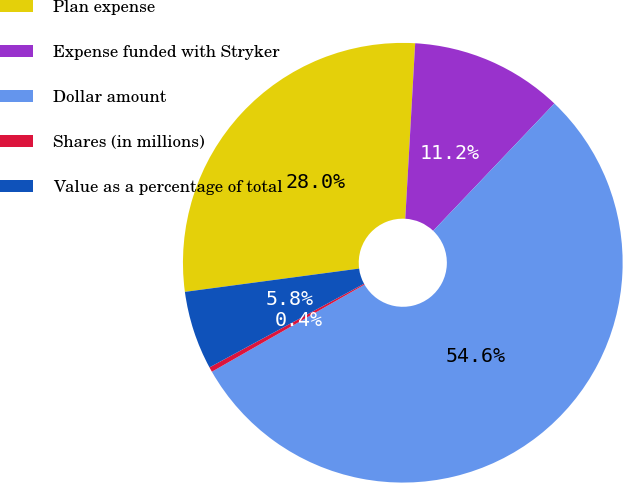Convert chart. <chart><loc_0><loc_0><loc_500><loc_500><pie_chart><fcel>Plan expense<fcel>Expense funded with Stryker<fcel>Dollar amount<fcel>Shares (in millions)<fcel>Value as a percentage of total<nl><fcel>28.01%<fcel>11.21%<fcel>54.63%<fcel>0.36%<fcel>5.78%<nl></chart> 